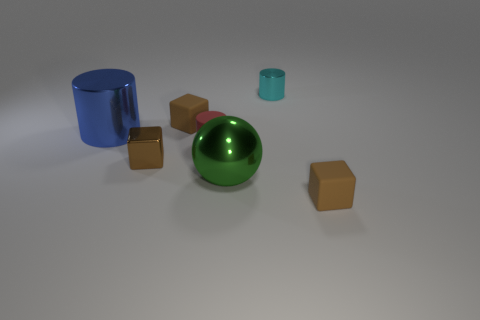Subtract all brown cubes. How many were subtracted if there are1brown cubes left? 2 Subtract all metallic cylinders. How many cylinders are left? 1 Add 3 cylinders. How many objects exist? 10 Subtract all balls. How many objects are left? 6 Subtract 1 blocks. How many blocks are left? 2 Add 6 small cyan things. How many small cyan things are left? 7 Add 1 large matte spheres. How many large matte spheres exist? 1 Subtract 0 red balls. How many objects are left? 7 Subtract all purple spheres. Subtract all red cubes. How many spheres are left? 1 Subtract all tiny cyan shiny objects. Subtract all metal cylinders. How many objects are left? 4 